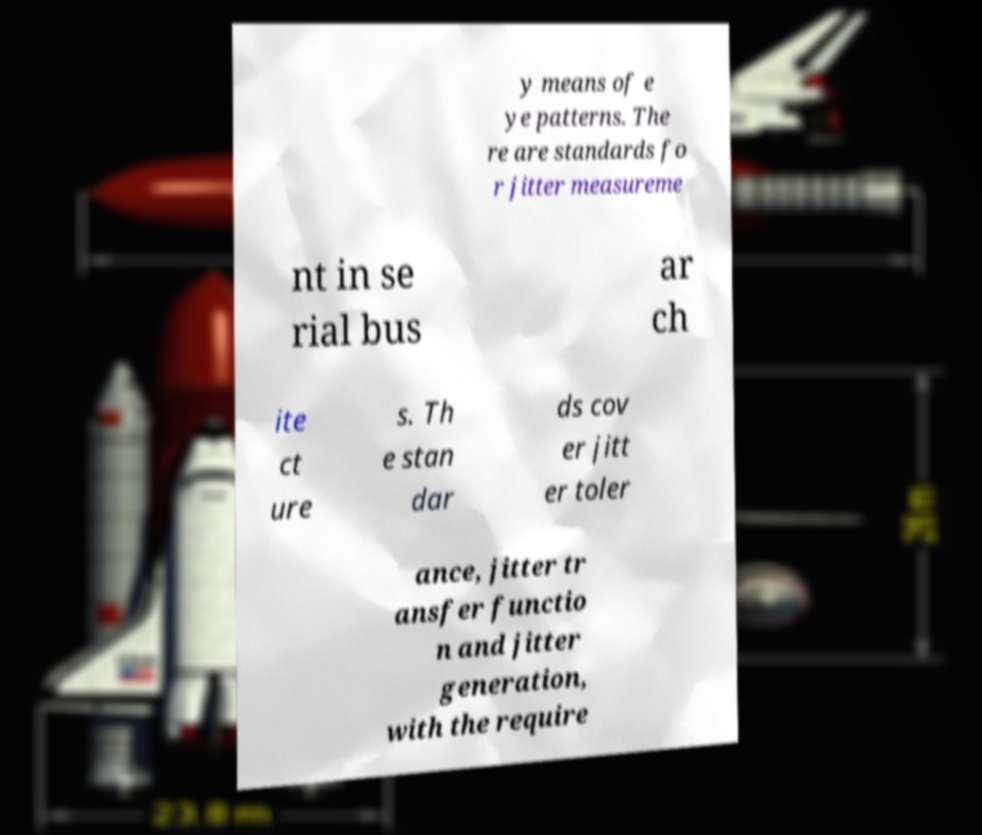Could you extract and type out the text from this image? y means of e ye patterns. The re are standards fo r jitter measureme nt in se rial bus ar ch ite ct ure s. Th e stan dar ds cov er jitt er toler ance, jitter tr ansfer functio n and jitter generation, with the require 